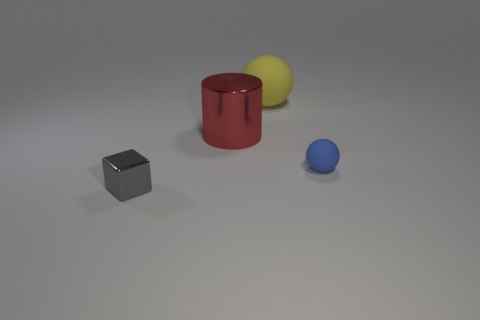How many large objects are the same color as the cylinder?
Make the answer very short. 0. Are there more big rubber spheres that are in front of the tiny ball than big matte cylinders?
Offer a very short reply. No. Do the gray shiny thing and the big red metallic thing have the same shape?
Provide a short and direct response. No. What number of large brown things have the same material as the large ball?
Your answer should be very brief. 0. What is the size of the blue thing that is the same shape as the big yellow thing?
Offer a terse response. Small. Do the blue ball and the gray metal object have the same size?
Make the answer very short. Yes. There is a tiny thing that is on the left side of the sphere that is behind the tiny thing that is behind the gray block; what shape is it?
Provide a short and direct response. Cube. The other large rubber thing that is the same shape as the blue matte thing is what color?
Your answer should be compact. Yellow. There is a object that is behind the small blue matte object and in front of the big yellow matte sphere; what size is it?
Keep it short and to the point. Large. What number of red metallic objects are left of the shiny thing behind the thing that is left of the large metallic cylinder?
Your answer should be compact. 0. 